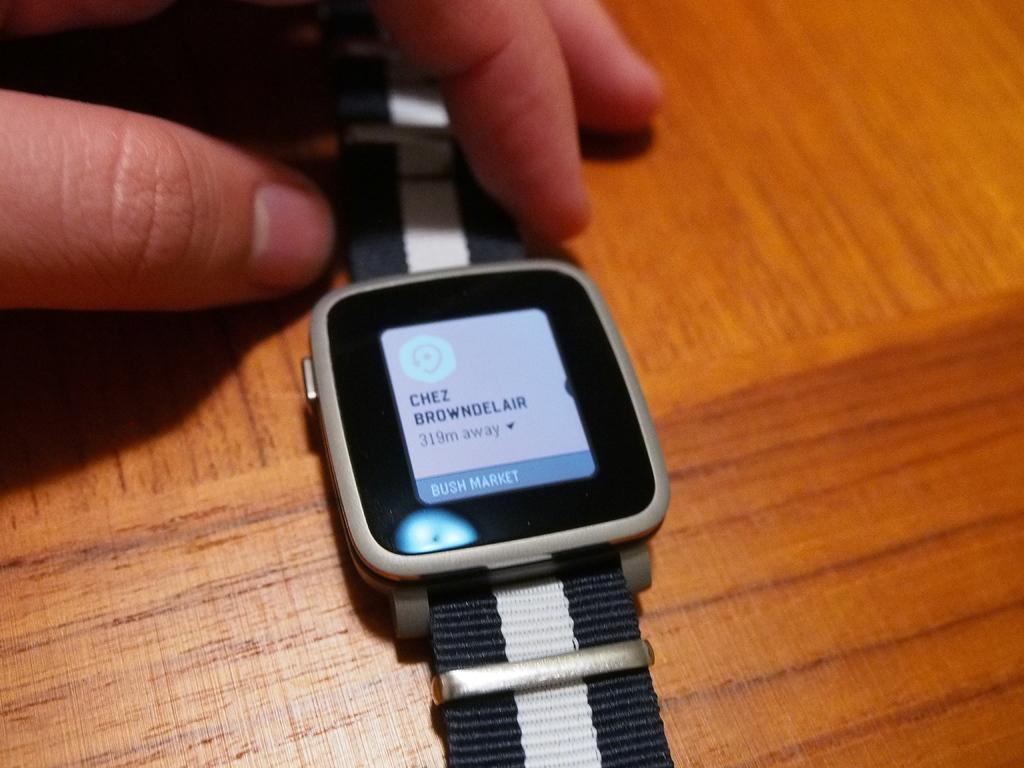What is the distance to chez browndelair?
Make the answer very short. 319m. What is the first letter on the watch?
Ensure brevity in your answer.  C. 